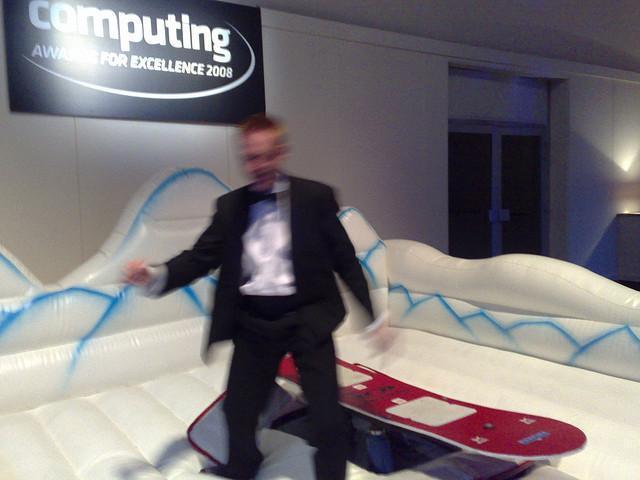How many floor tiles with any part of a cat on them are in the picture?
Give a very brief answer. 0. 